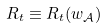<formula> <loc_0><loc_0><loc_500><loc_500>R _ { t } \equiv R _ { t } ( w _ { \mathcal { A } } )</formula> 